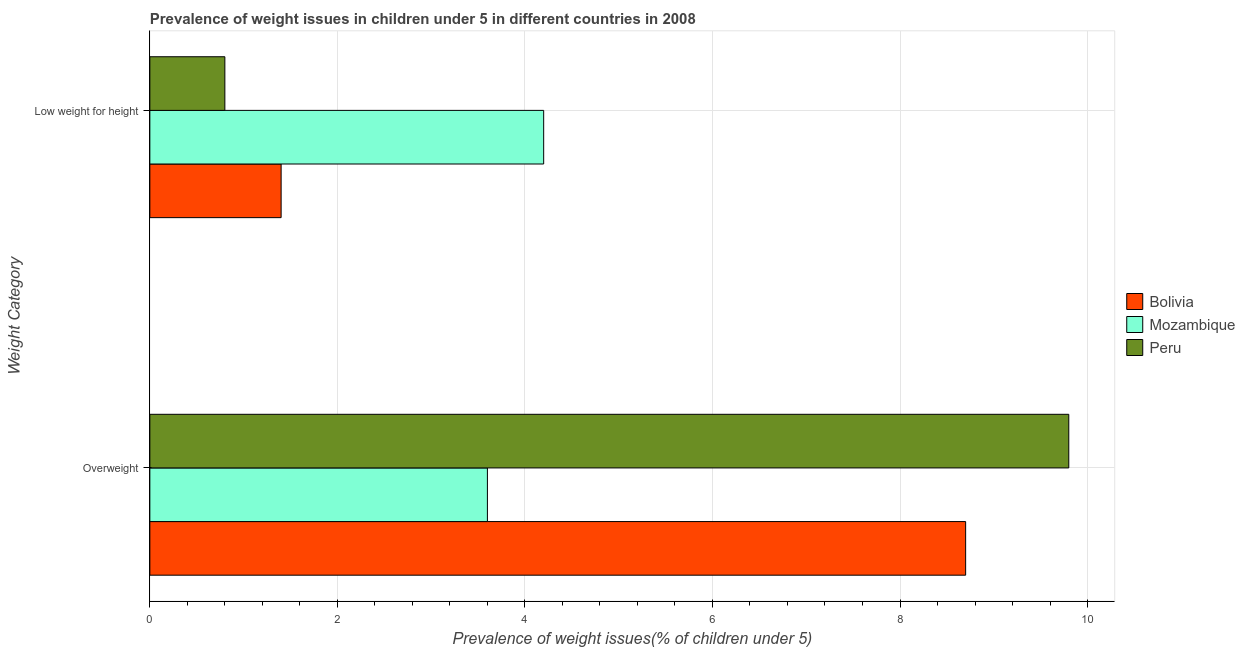How many groups of bars are there?
Your answer should be compact. 2. Are the number of bars per tick equal to the number of legend labels?
Your answer should be compact. Yes. Are the number of bars on each tick of the Y-axis equal?
Make the answer very short. Yes. How many bars are there on the 1st tick from the top?
Your answer should be compact. 3. What is the label of the 2nd group of bars from the top?
Your answer should be very brief. Overweight. What is the percentage of underweight children in Mozambique?
Provide a short and direct response. 4.2. Across all countries, what is the maximum percentage of overweight children?
Your answer should be compact. 9.8. Across all countries, what is the minimum percentage of underweight children?
Keep it short and to the point. 0.8. In which country was the percentage of underweight children maximum?
Your response must be concise. Mozambique. In which country was the percentage of overweight children minimum?
Provide a succinct answer. Mozambique. What is the total percentage of underweight children in the graph?
Offer a terse response. 6.4. What is the difference between the percentage of overweight children in Mozambique and that in Peru?
Your answer should be very brief. -6.2. What is the difference between the percentage of underweight children in Mozambique and the percentage of overweight children in Peru?
Your answer should be compact. -5.6. What is the average percentage of overweight children per country?
Give a very brief answer. 7.37. What is the difference between the percentage of underweight children and percentage of overweight children in Peru?
Offer a very short reply. -9. What is the ratio of the percentage of underweight children in Mozambique to that in Bolivia?
Give a very brief answer. 3. What does the 2nd bar from the top in Low weight for height represents?
Ensure brevity in your answer.  Mozambique. How many bars are there?
Ensure brevity in your answer.  6. Are all the bars in the graph horizontal?
Keep it short and to the point. Yes. What is the difference between two consecutive major ticks on the X-axis?
Provide a short and direct response. 2. Does the graph contain any zero values?
Keep it short and to the point. No. How are the legend labels stacked?
Provide a succinct answer. Vertical. What is the title of the graph?
Offer a very short reply. Prevalence of weight issues in children under 5 in different countries in 2008. What is the label or title of the X-axis?
Your answer should be very brief. Prevalence of weight issues(% of children under 5). What is the label or title of the Y-axis?
Offer a very short reply. Weight Category. What is the Prevalence of weight issues(% of children under 5) of Bolivia in Overweight?
Your response must be concise. 8.7. What is the Prevalence of weight issues(% of children under 5) in Mozambique in Overweight?
Keep it short and to the point. 3.6. What is the Prevalence of weight issues(% of children under 5) of Peru in Overweight?
Your response must be concise. 9.8. What is the Prevalence of weight issues(% of children under 5) of Bolivia in Low weight for height?
Offer a terse response. 1.4. What is the Prevalence of weight issues(% of children under 5) of Mozambique in Low weight for height?
Offer a very short reply. 4.2. What is the Prevalence of weight issues(% of children under 5) in Peru in Low weight for height?
Provide a succinct answer. 0.8. Across all Weight Category, what is the maximum Prevalence of weight issues(% of children under 5) in Bolivia?
Your answer should be compact. 8.7. Across all Weight Category, what is the maximum Prevalence of weight issues(% of children under 5) of Mozambique?
Offer a terse response. 4.2. Across all Weight Category, what is the maximum Prevalence of weight issues(% of children under 5) of Peru?
Your answer should be very brief. 9.8. Across all Weight Category, what is the minimum Prevalence of weight issues(% of children under 5) of Bolivia?
Ensure brevity in your answer.  1.4. Across all Weight Category, what is the minimum Prevalence of weight issues(% of children under 5) in Mozambique?
Provide a short and direct response. 3.6. Across all Weight Category, what is the minimum Prevalence of weight issues(% of children under 5) of Peru?
Your answer should be very brief. 0.8. What is the total Prevalence of weight issues(% of children under 5) in Bolivia in the graph?
Your answer should be very brief. 10.1. What is the difference between the Prevalence of weight issues(% of children under 5) in Bolivia in Overweight and the Prevalence of weight issues(% of children under 5) in Peru in Low weight for height?
Offer a very short reply. 7.9. What is the average Prevalence of weight issues(% of children under 5) of Bolivia per Weight Category?
Make the answer very short. 5.05. What is the average Prevalence of weight issues(% of children under 5) of Mozambique per Weight Category?
Your answer should be compact. 3.9. What is the difference between the Prevalence of weight issues(% of children under 5) of Bolivia and Prevalence of weight issues(% of children under 5) of Mozambique in Overweight?
Ensure brevity in your answer.  5.1. What is the difference between the Prevalence of weight issues(% of children under 5) in Bolivia and Prevalence of weight issues(% of children under 5) in Peru in Low weight for height?
Provide a succinct answer. 0.6. What is the difference between the Prevalence of weight issues(% of children under 5) of Mozambique and Prevalence of weight issues(% of children under 5) of Peru in Low weight for height?
Give a very brief answer. 3.4. What is the ratio of the Prevalence of weight issues(% of children under 5) of Bolivia in Overweight to that in Low weight for height?
Keep it short and to the point. 6.21. What is the ratio of the Prevalence of weight issues(% of children under 5) in Mozambique in Overweight to that in Low weight for height?
Provide a short and direct response. 0.86. What is the ratio of the Prevalence of weight issues(% of children under 5) in Peru in Overweight to that in Low weight for height?
Give a very brief answer. 12.25. What is the difference between the highest and the lowest Prevalence of weight issues(% of children under 5) in Bolivia?
Make the answer very short. 7.3. What is the difference between the highest and the lowest Prevalence of weight issues(% of children under 5) of Mozambique?
Keep it short and to the point. 0.6. 